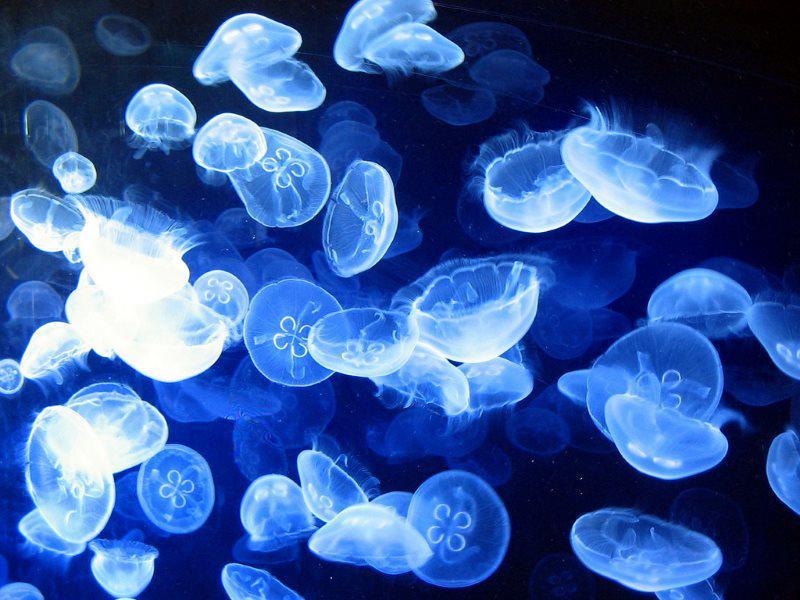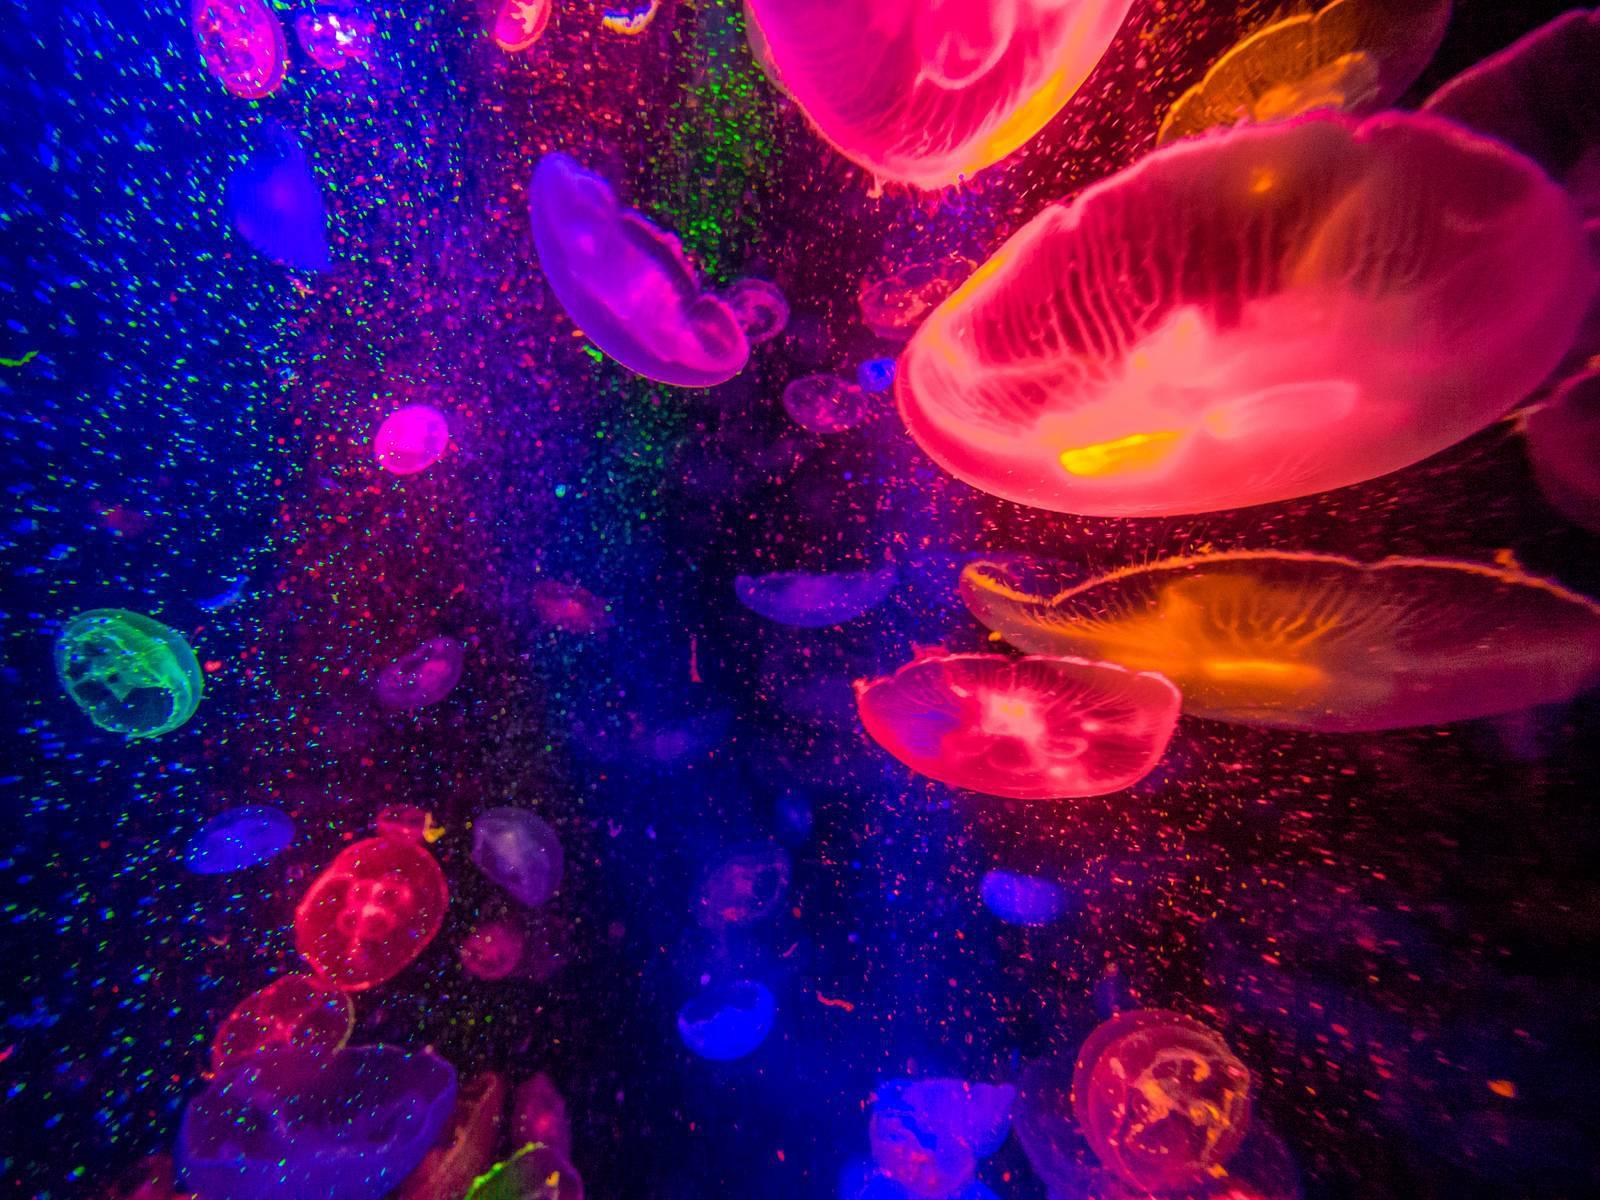The first image is the image on the left, the second image is the image on the right. For the images shown, is this caption "At least one image shows jellyfish of different colors." true? Answer yes or no. Yes. 